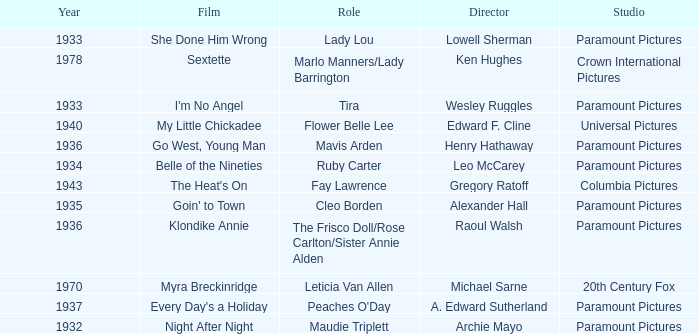What is the Year of the Film Belle of the Nineties? 1934.0. 